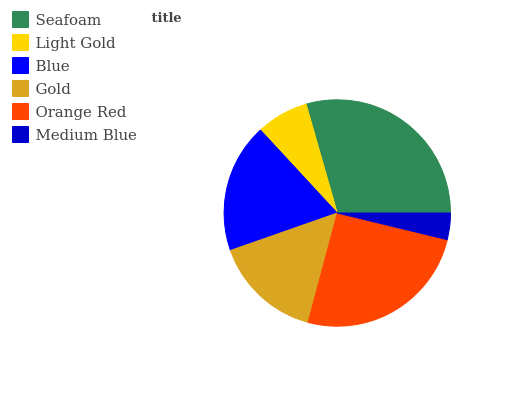Is Medium Blue the minimum?
Answer yes or no. Yes. Is Seafoam the maximum?
Answer yes or no. Yes. Is Light Gold the minimum?
Answer yes or no. No. Is Light Gold the maximum?
Answer yes or no. No. Is Seafoam greater than Light Gold?
Answer yes or no. Yes. Is Light Gold less than Seafoam?
Answer yes or no. Yes. Is Light Gold greater than Seafoam?
Answer yes or no. No. Is Seafoam less than Light Gold?
Answer yes or no. No. Is Blue the high median?
Answer yes or no. Yes. Is Gold the low median?
Answer yes or no. Yes. Is Orange Red the high median?
Answer yes or no. No. Is Light Gold the low median?
Answer yes or no. No. 